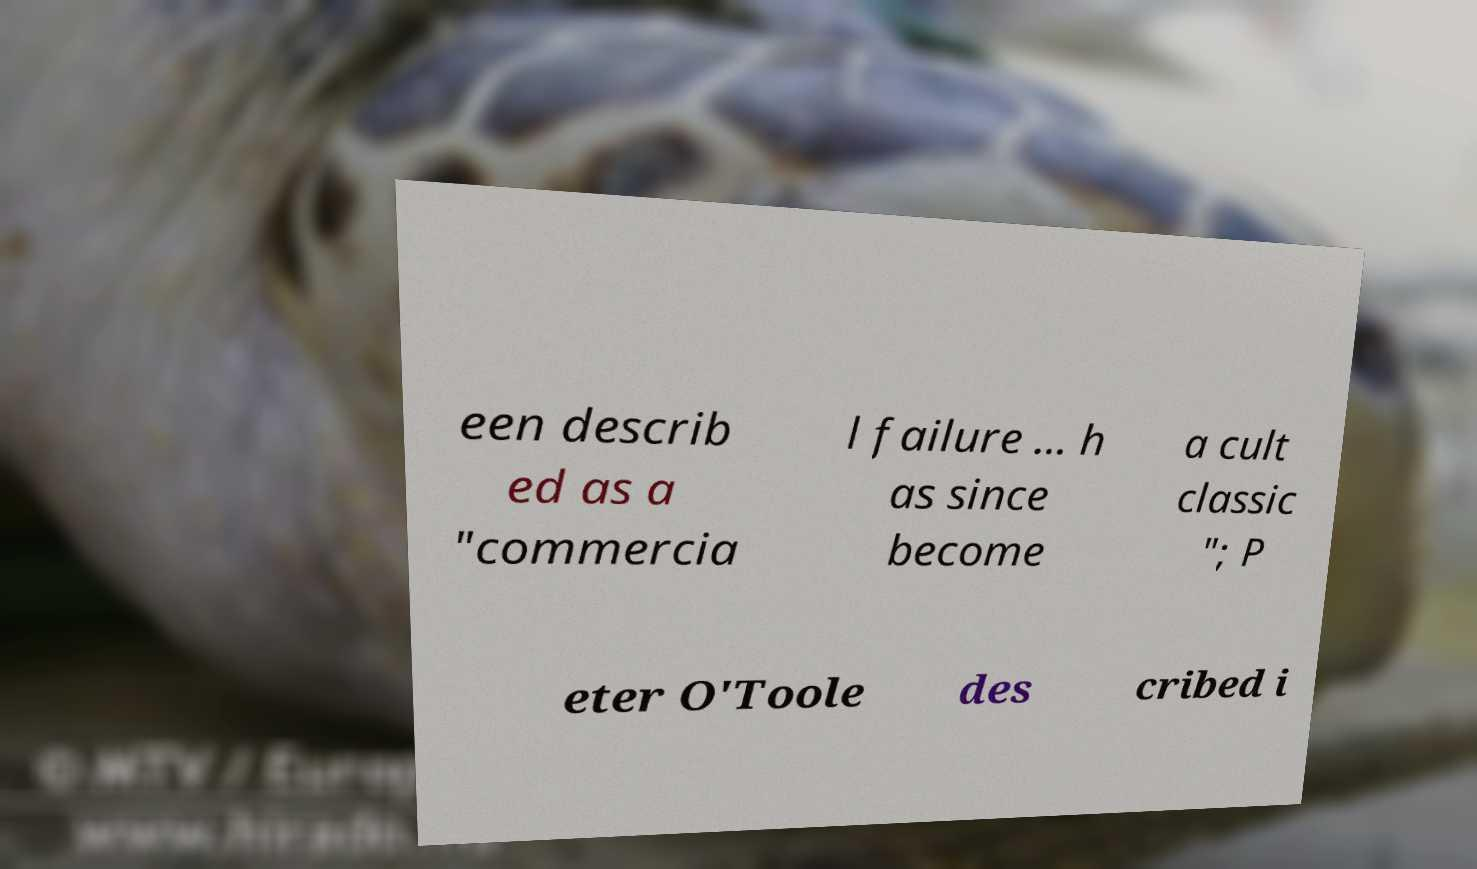For documentation purposes, I need the text within this image transcribed. Could you provide that? een describ ed as a "commercia l failure ... h as since become a cult classic "; P eter O'Toole des cribed i 